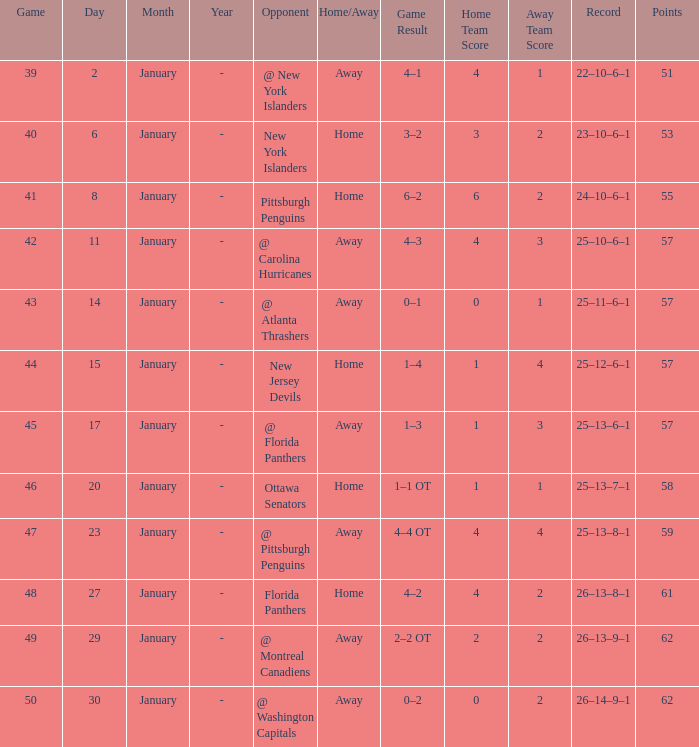What is the median for january with points of 51? 2.0. 